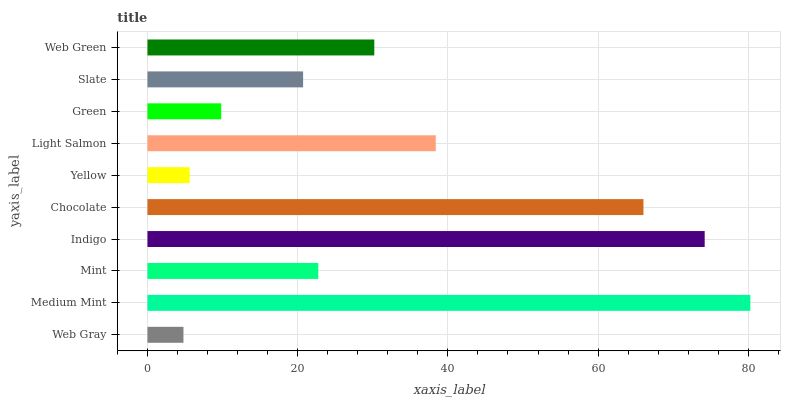Is Web Gray the minimum?
Answer yes or no. Yes. Is Medium Mint the maximum?
Answer yes or no. Yes. Is Mint the minimum?
Answer yes or no. No. Is Mint the maximum?
Answer yes or no. No. Is Medium Mint greater than Mint?
Answer yes or no. Yes. Is Mint less than Medium Mint?
Answer yes or no. Yes. Is Mint greater than Medium Mint?
Answer yes or no. No. Is Medium Mint less than Mint?
Answer yes or no. No. Is Web Green the high median?
Answer yes or no. Yes. Is Mint the low median?
Answer yes or no. Yes. Is Medium Mint the high median?
Answer yes or no. No. Is Indigo the low median?
Answer yes or no. No. 